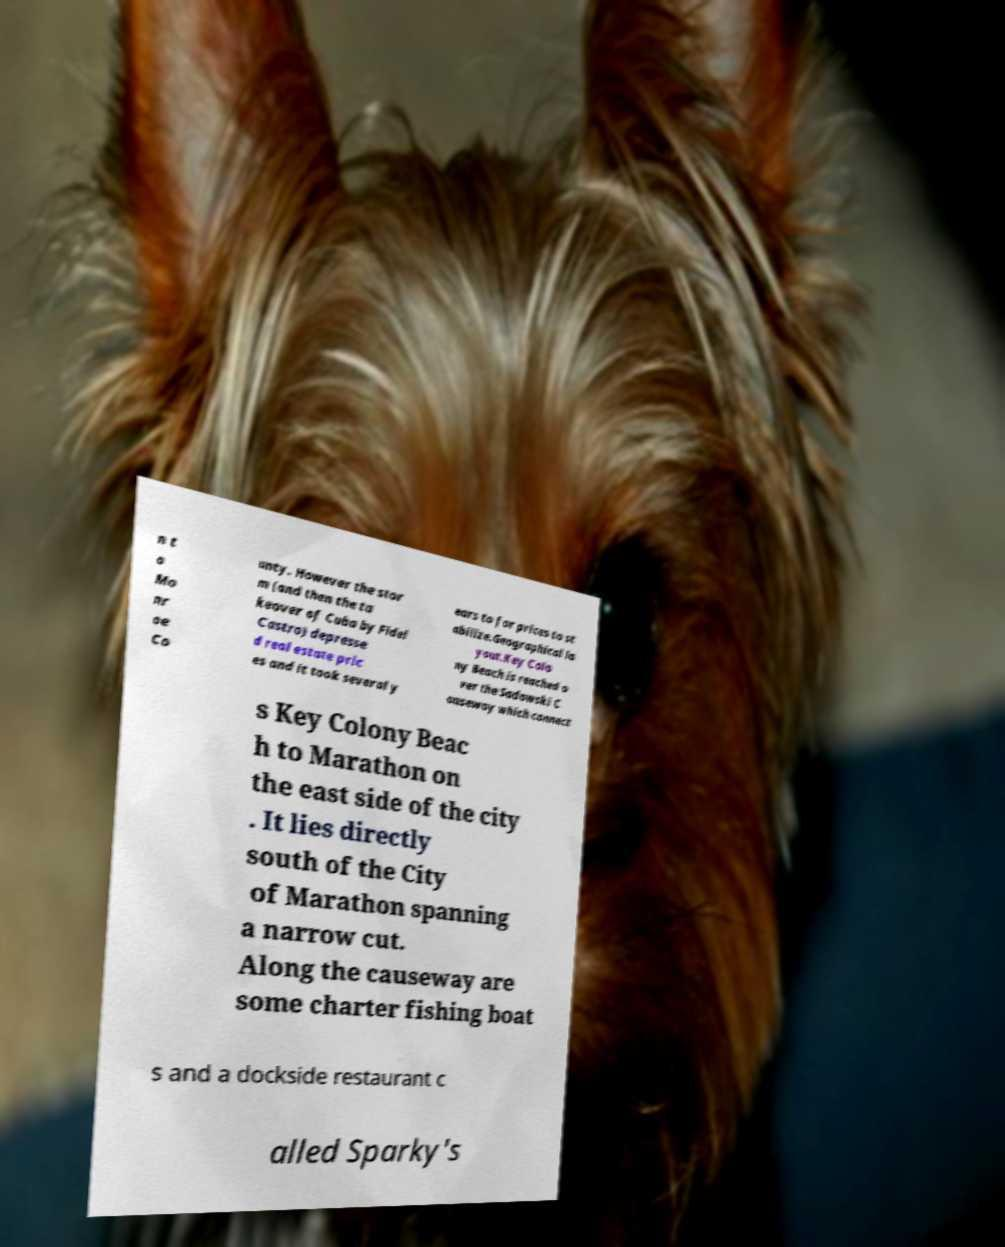Please read and relay the text visible in this image. What does it say? n t o Mo nr oe Co unty. However the stor m (and then the ta keover of Cuba by Fidel Castro) depresse d real estate pric es and it took several y ears to for prices to st abilize.Geographical la yout.Key Colo ny Beach is reached o ver the Sadowski C auseway which connect s Key Colony Beac h to Marathon on the east side of the city . It lies directly south of the City of Marathon spanning a narrow cut. Along the causeway are some charter fishing boat s and a dockside restaurant c alled Sparky's 